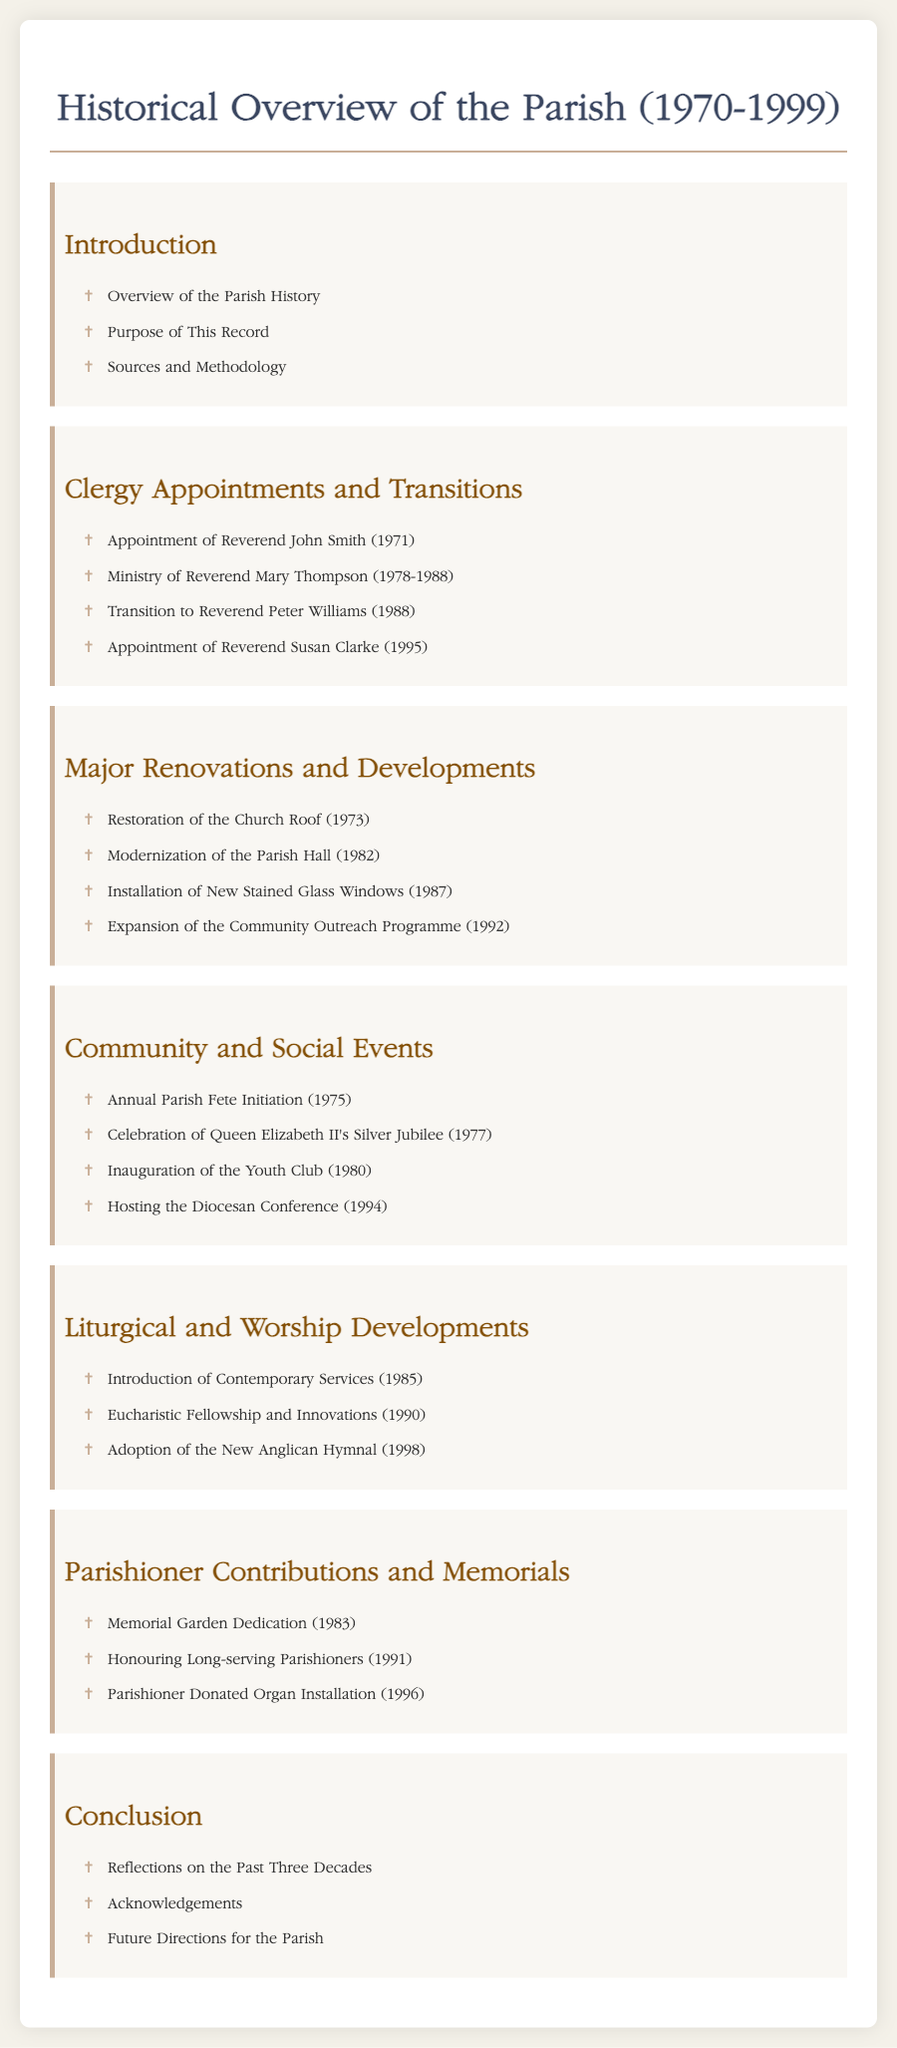what significant renovation occurred in 1973? The document details that the restoration of the church roof took place in 1973.
Answer: Restoration of the Church Roof who served as the minister from 1978 to 1988? Reverend Mary Thompson is noted in the document as serving during this period.
Answer: Reverend Mary Thompson which event was initiated in 1975? The document states that the annual parish fete was initiated in this year.
Answer: Annual Parish Fete Initiation what year was the Youth Club inaugurated? The document specifies that the Youth Club was inaugurated in 1980.
Answer: 1980 how many clergy appointments are listed in the document? The document lists four significant clergy appointments during the time frame.
Answer: Four what new service type was introduced in 1985? It states that contemporary services were introduced in this year.
Answer: Contemporary Services which significant memorial activity occurred in 1983? The dedication of the memorial garden is noted as occurring in 1983.
Answer: Memorial Garden Dedication what is emphasized in the conclusion section? Reflections on the past three decades are mentioned as a focus of the conclusion.
Answer: Reflections on the Past Three Decades 